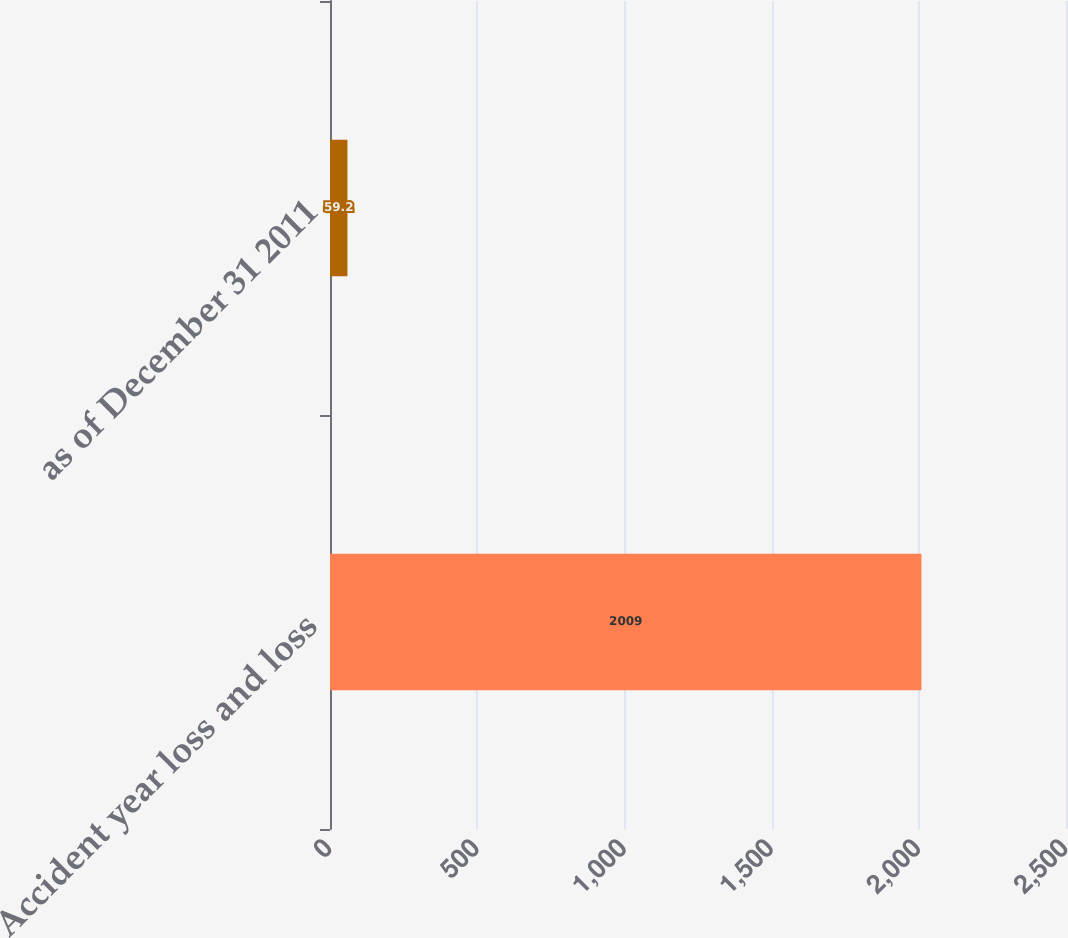<chart> <loc_0><loc_0><loc_500><loc_500><bar_chart><fcel>Accident year loss and loss<fcel>as of December 31 2011<nl><fcel>2009<fcel>59.2<nl></chart> 